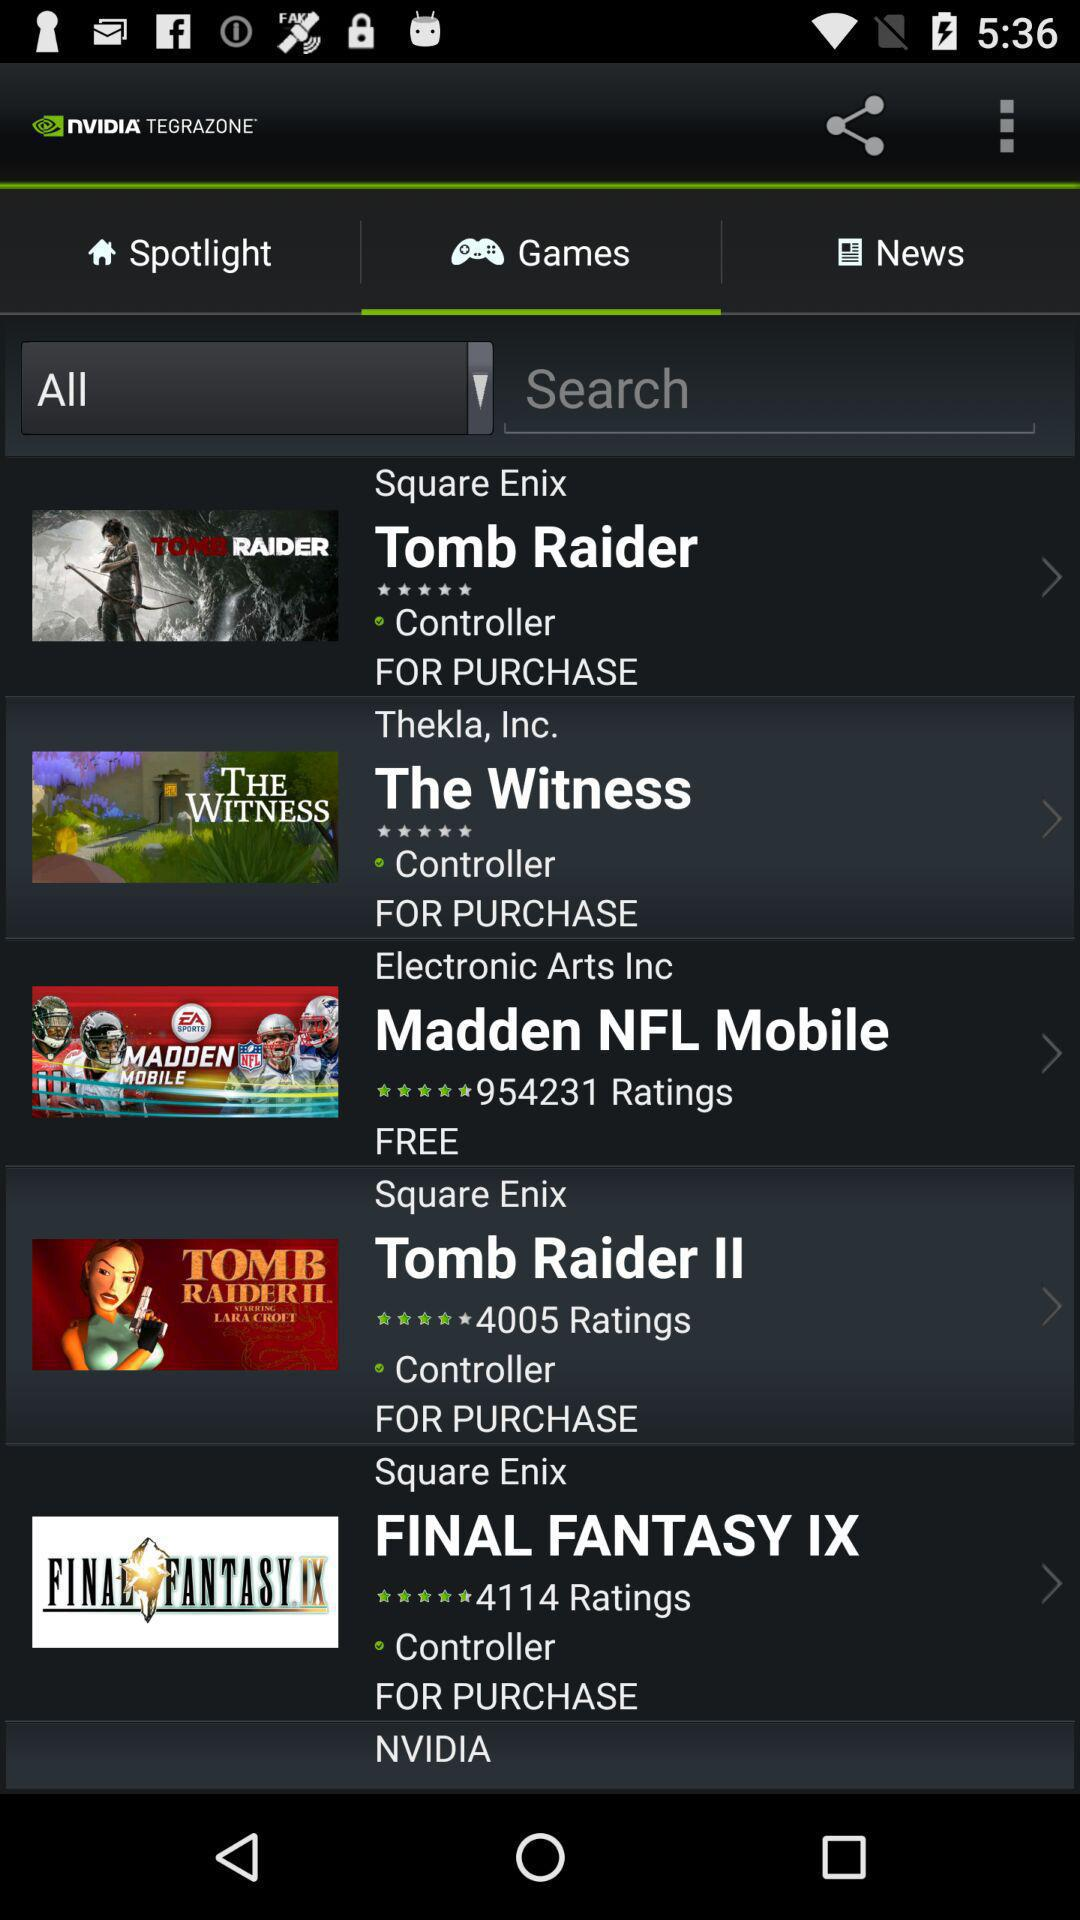What are the games? The games are "Tomb Raider", "The Witness", "Madden NFL Mobile", "Tomb Raider II", and "FINAL FANTASY IX". 